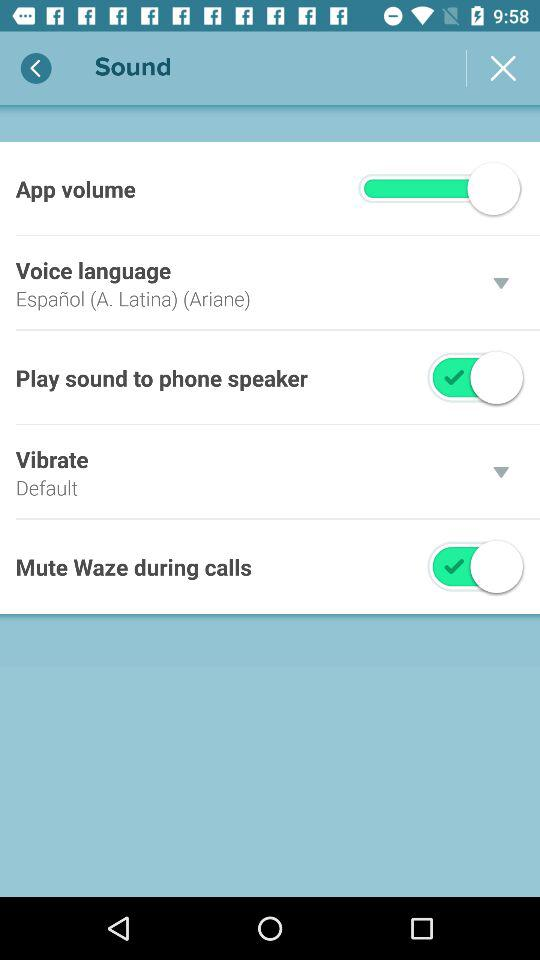Which voice language has been selected? The voice language that has been selected is "Español (A. Latina) (Ariane)". 